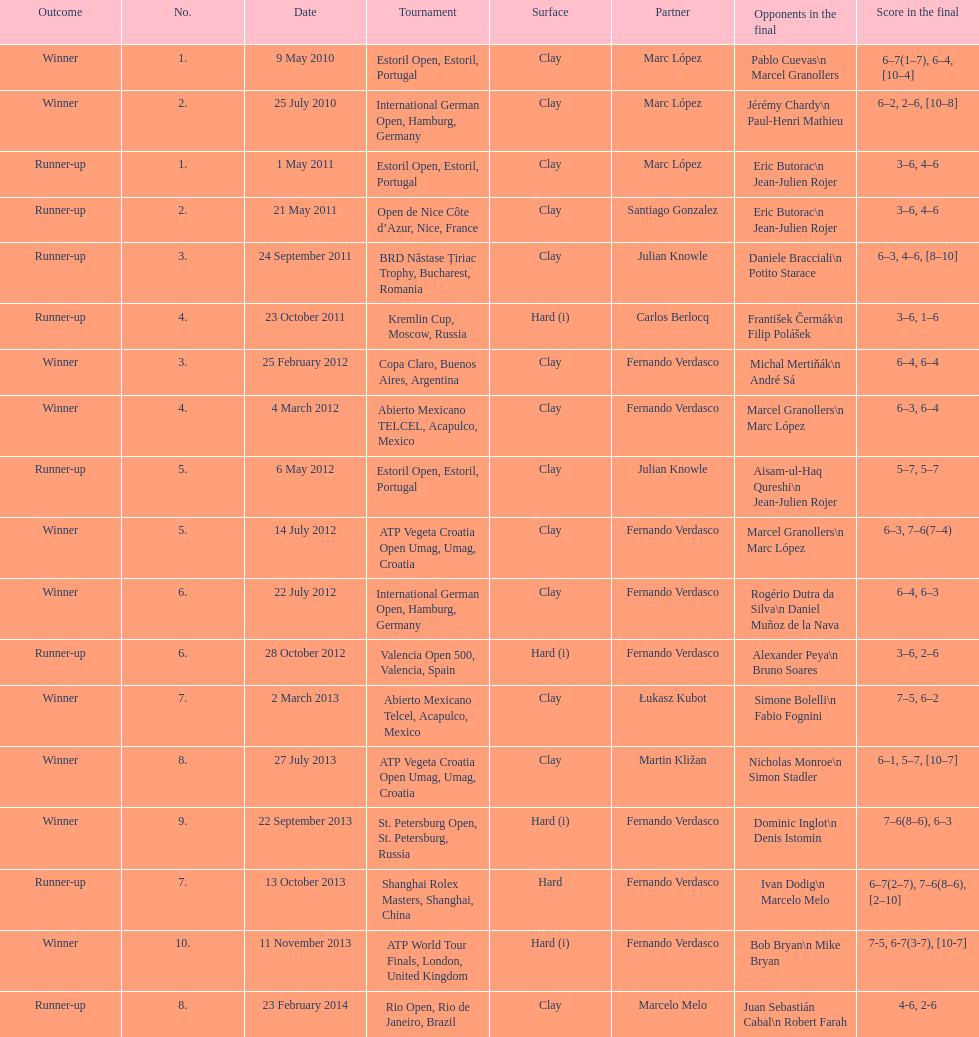Who was this athlete's subsequent teammate after competing alongside marc lopez in may 2011? Santiago Gonzalez. 